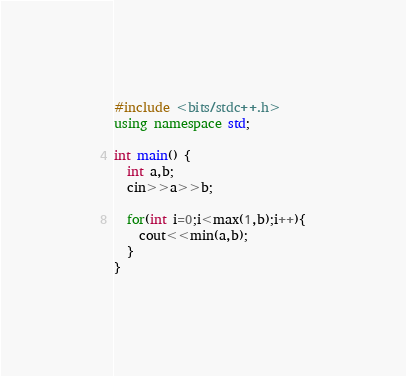<code> <loc_0><loc_0><loc_500><loc_500><_C++_>#include <bits/stdc++.h>
using namespace std;

int main() {
  int a,b;
  cin>>a>>b;
  
  for(int i=0;i<max(1,b);i++){
    cout<<min(a,b);
  }
}</code> 